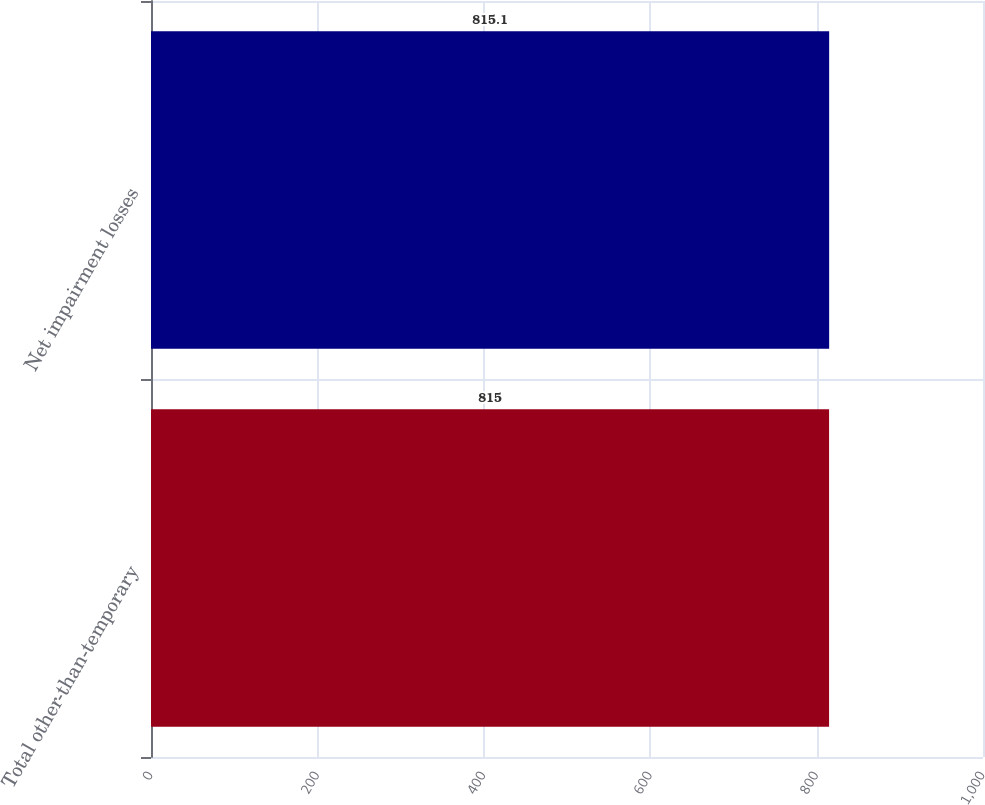Convert chart. <chart><loc_0><loc_0><loc_500><loc_500><bar_chart><fcel>Total other-than-temporary<fcel>Net impairment losses<nl><fcel>815<fcel>815.1<nl></chart> 